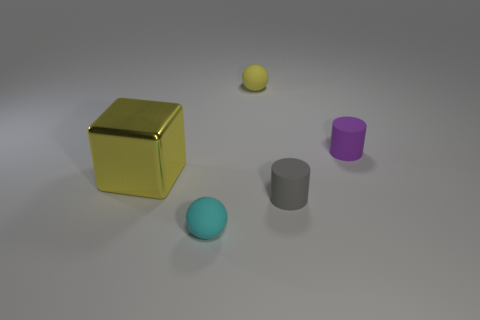Is there anything else that has the same material as the big thing?
Make the answer very short. No. There is a yellow object behind the tiny purple rubber thing; is its shape the same as the small matte object to the right of the gray object?
Offer a terse response. No. What number of objects are either yellow metallic things or large spheres?
Keep it short and to the point. 1. The ball on the left side of the tiny matte sphere behind the small cyan matte thing is made of what material?
Provide a short and direct response. Rubber. Is there a tiny rubber cylinder of the same color as the big metallic thing?
Ensure brevity in your answer.  No. There is another rubber cylinder that is the same size as the gray matte cylinder; what is its color?
Your answer should be compact. Purple. There is a tiny thing that is on the left side of the ball that is behind the cylinder that is behind the gray matte thing; what is it made of?
Your response must be concise. Rubber. Do the block and the rubber cylinder that is in front of the purple thing have the same color?
Keep it short and to the point. No. What number of things are tiny matte objects that are right of the small yellow rubber object or rubber objects that are in front of the purple matte cylinder?
Keep it short and to the point. 3. What shape is the small matte object in front of the cylinder in front of the purple thing?
Make the answer very short. Sphere. 